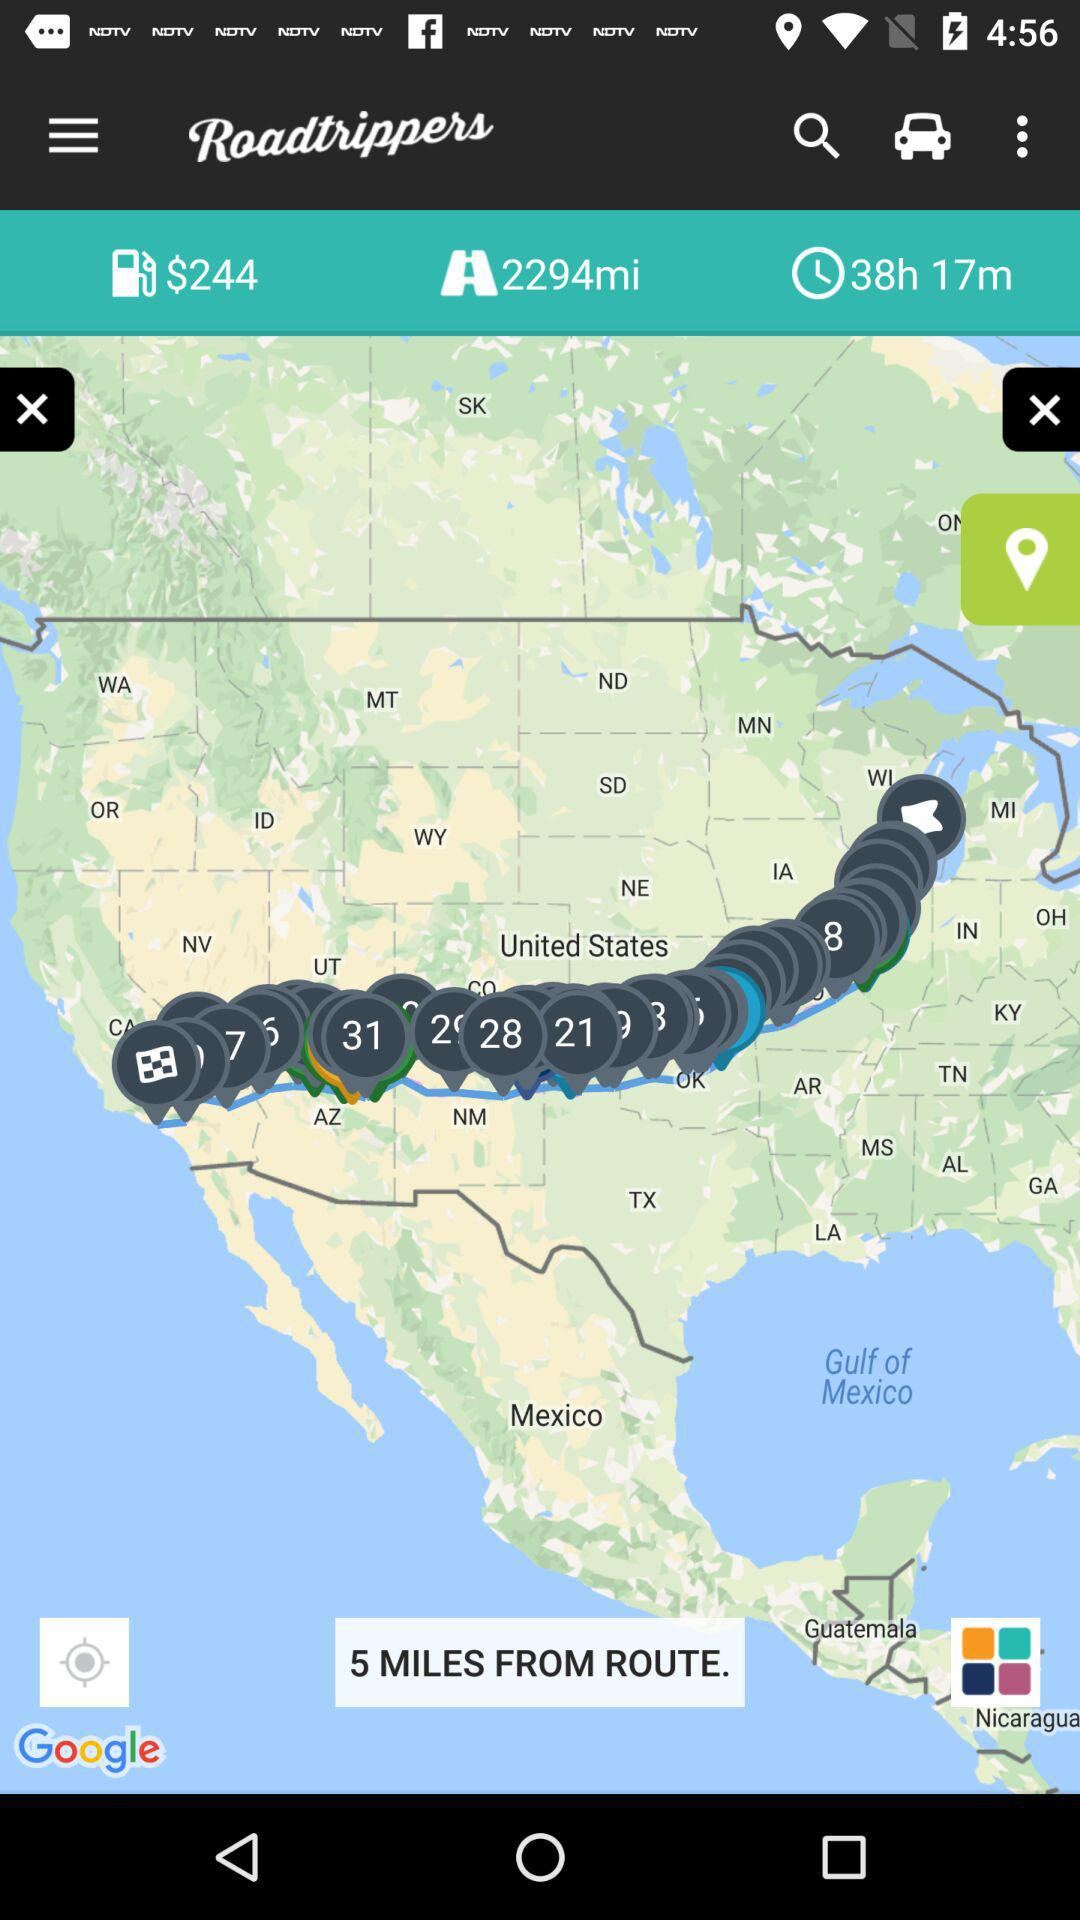What is the application name? The application name is "Roadtrippers". 